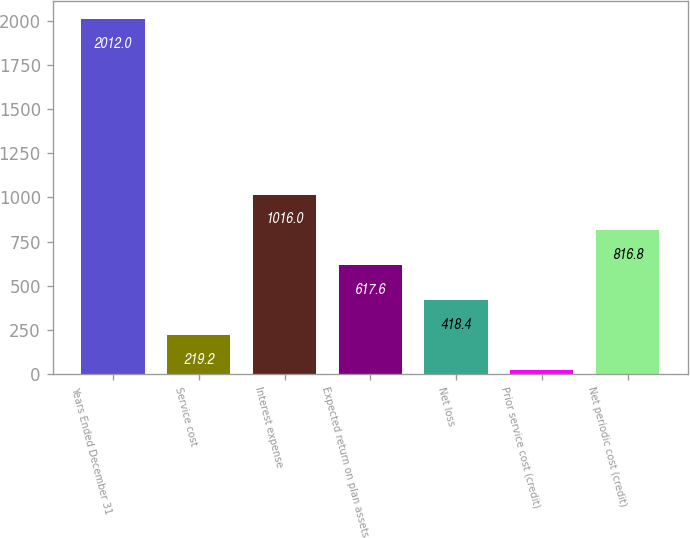Convert chart to OTSL. <chart><loc_0><loc_0><loc_500><loc_500><bar_chart><fcel>Years Ended December 31<fcel>Service cost<fcel>Interest expense<fcel>Expected return on plan assets<fcel>Net loss<fcel>Prior service cost (credit)<fcel>Net periodic cost (credit)<nl><fcel>2012<fcel>219.2<fcel>1016<fcel>617.6<fcel>418.4<fcel>20<fcel>816.8<nl></chart> 